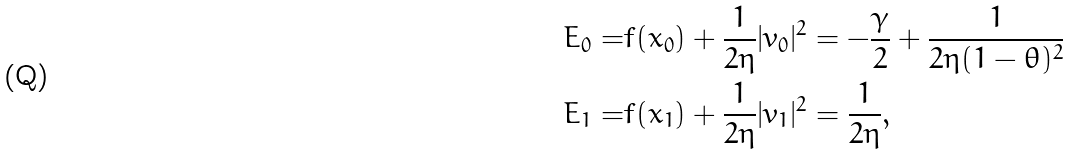<formula> <loc_0><loc_0><loc_500><loc_500>E _ { 0 } = & f ( x _ { 0 } ) + \frac { 1 } { 2 \eta } | v _ { 0 } | ^ { 2 } = - \frac { \gamma } { 2 } + \frac { 1 } { 2 \eta ( 1 - \theta ) ^ { 2 } } \\ E _ { 1 } = & f ( x _ { 1 } ) + \frac { 1 } { 2 \eta } | v _ { 1 } | ^ { 2 } = \frac { 1 } { 2 \eta } ,</formula> 